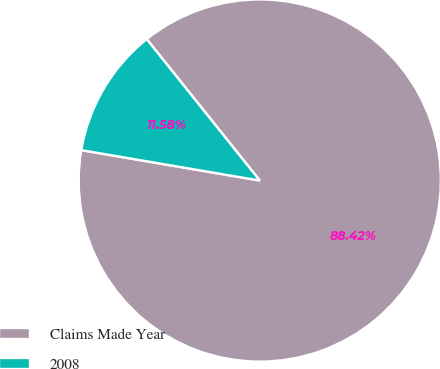<chart> <loc_0><loc_0><loc_500><loc_500><pie_chart><fcel>Claims Made Year<fcel>2008<nl><fcel>88.42%<fcel>11.58%<nl></chart> 